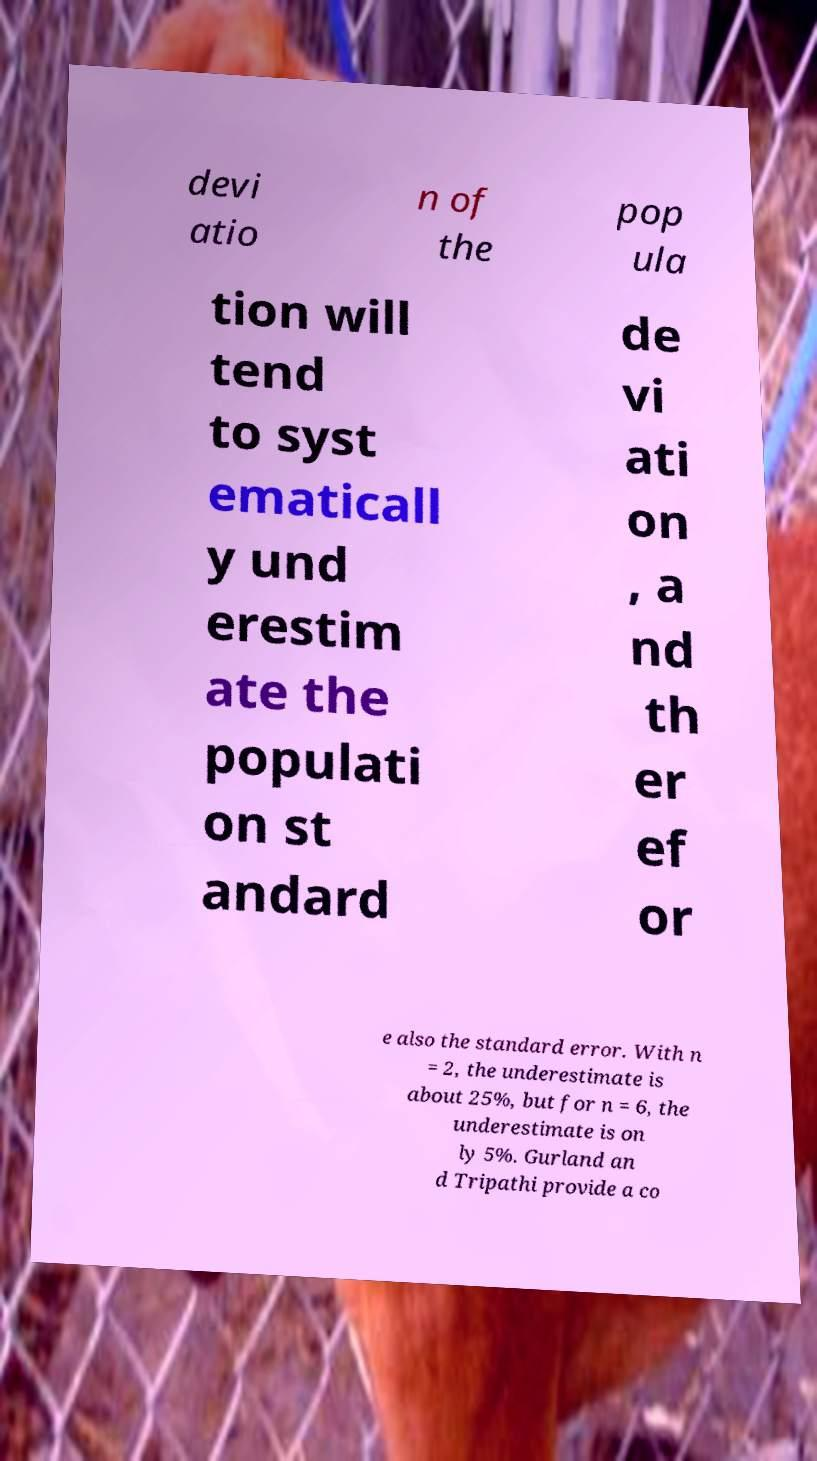Could you extract and type out the text from this image? devi atio n of the pop ula tion will tend to syst ematicall y und erestim ate the populati on st andard de vi ati on , a nd th er ef or e also the standard error. With n = 2, the underestimate is about 25%, but for n = 6, the underestimate is on ly 5%. Gurland an d Tripathi provide a co 